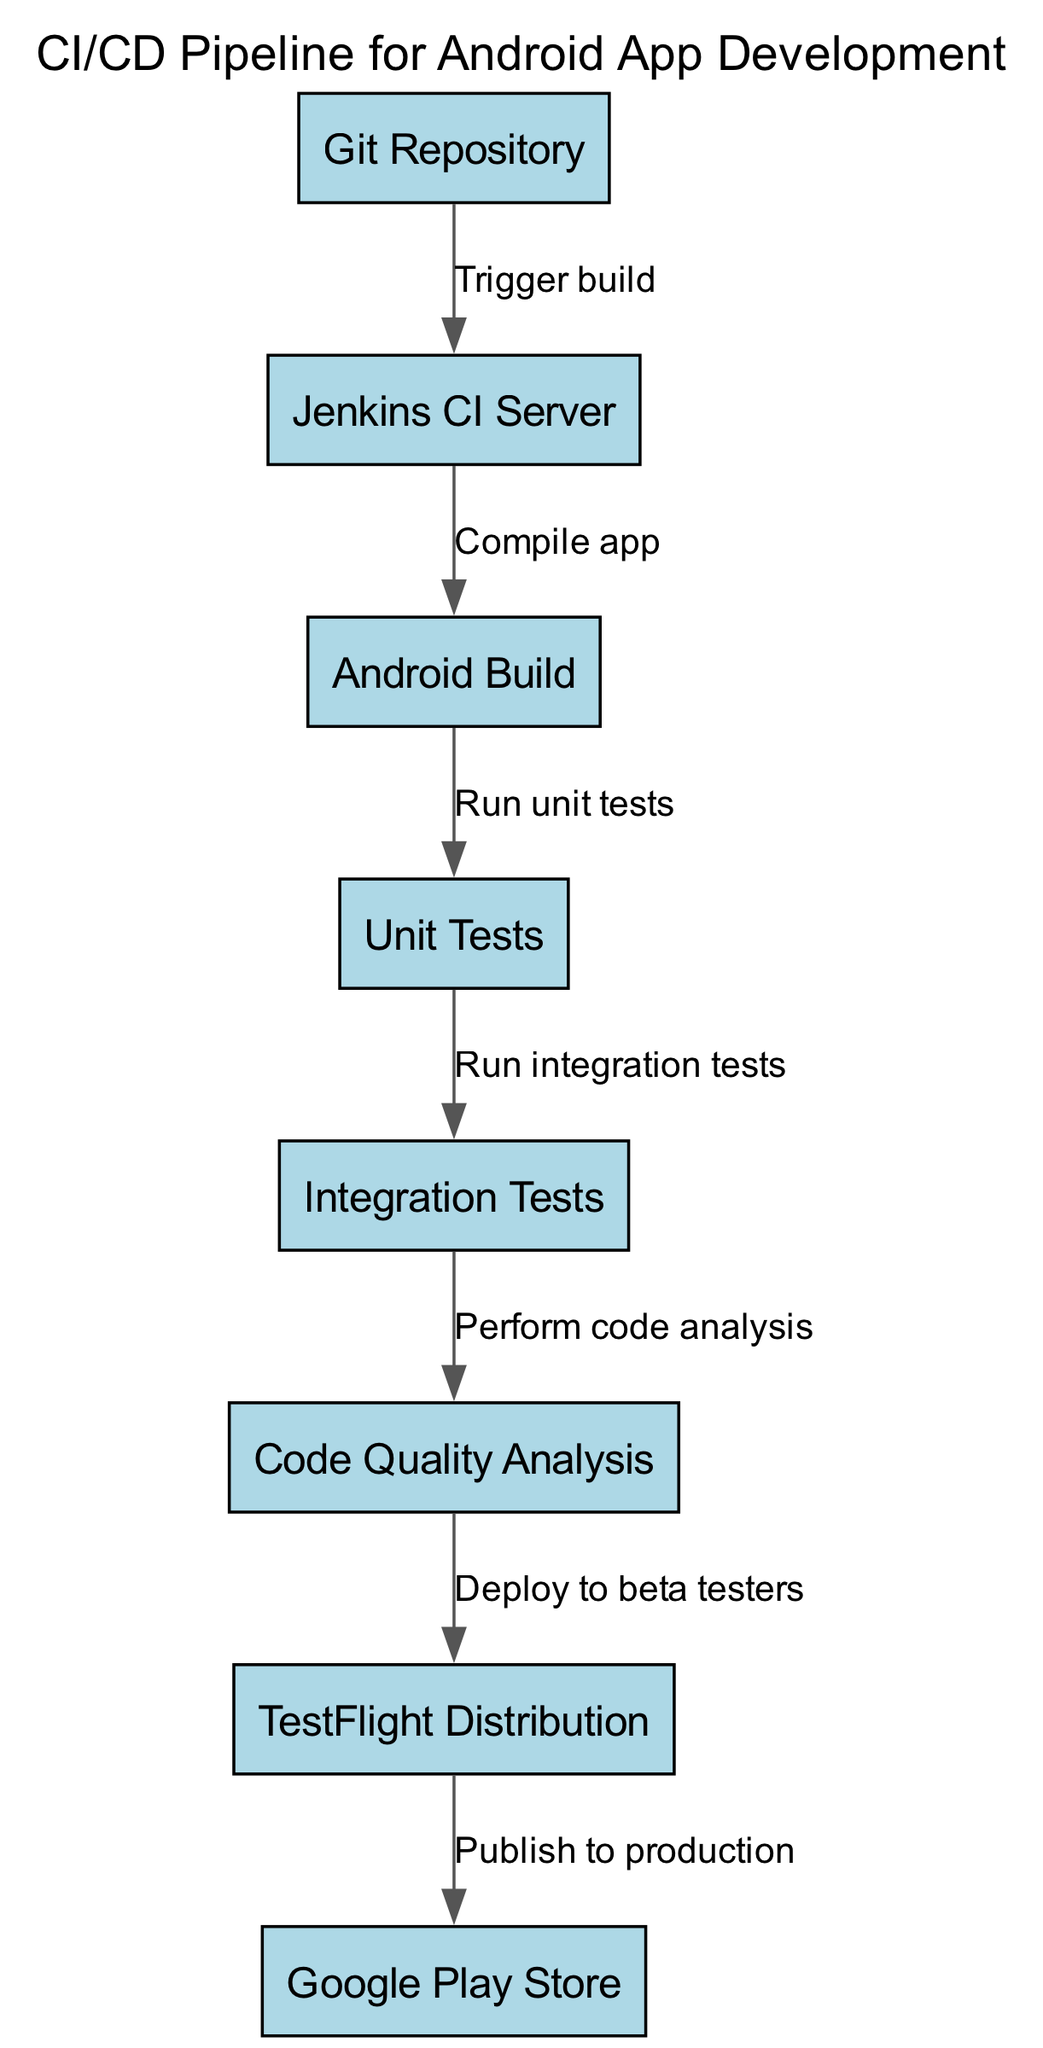What is the first node in the pipeline? The first node in the pipeline is the "Git Repository." This is established by looking at the diagram and identifying the starting point of the process.
Answer: Git Repository How many nodes are there in total? By counting each unique label in the diagram, we identify there are eight distinct nodes listed.
Answer: 8 What is the relationship between the "Android Build" and "Unit Tests"? The diagram illustrates that the "Android Build" node has a directed edge leading to the "Unit Tests" node, indicating that unit tests are run after the app has been built.
Answer: Run unit tests Which node performs "Code Quality Analysis"? From the diagram, it is clear that the "Code Quality Analysis" is performed at the node labeled as such, which follows after integration tests.
Answer: Code Quality Analysis What is the output destination of the deployment after "TestFlight Distribution"? The diagram shows that the output from "TestFlight Distribution" leads to the "Google Play Store," indicating that after beta testing, the app is published to production.
Answer: Google Play Store What is the last step in the CI/CD pipeline? The last step displayed in the diagram is the "Publish to production," indicating that once all tests and checks are completed, the app is officially released.
Answer: Publish to production Which two nodes are directly connected by the edge labeled "Trigger build"? The edge labeled "Trigger build" connects the "Git Repository" node to the "Jenkins CI Server" node, indicating that when a change is made in the Git repository, it triggers a build in Jenkins.
Answer: Git Repository, Jenkins CI Server Explain the sequence from "Integration Tests" to "Deploy to beta testers." The flow shows that after "Integration Tests" are completed, code analysis is performed. This process leads directly to the "Deploy to beta testers," indicating deployment occurs post-analysis.
Answer: Deploy to beta testers What is the flow of the pipeline starting from "Git Repository"? The pipeline flow starting from the "Git Repository" goes as follows: Trigger build → Jenkins CI Server → Android Build → Run unit tests → Run integration tests → Perform code analysis → Deploy to beta testers → Publish to production. This shows a clear sequence of actions performed on the code.
Answer: Trigger build to Publish to production 